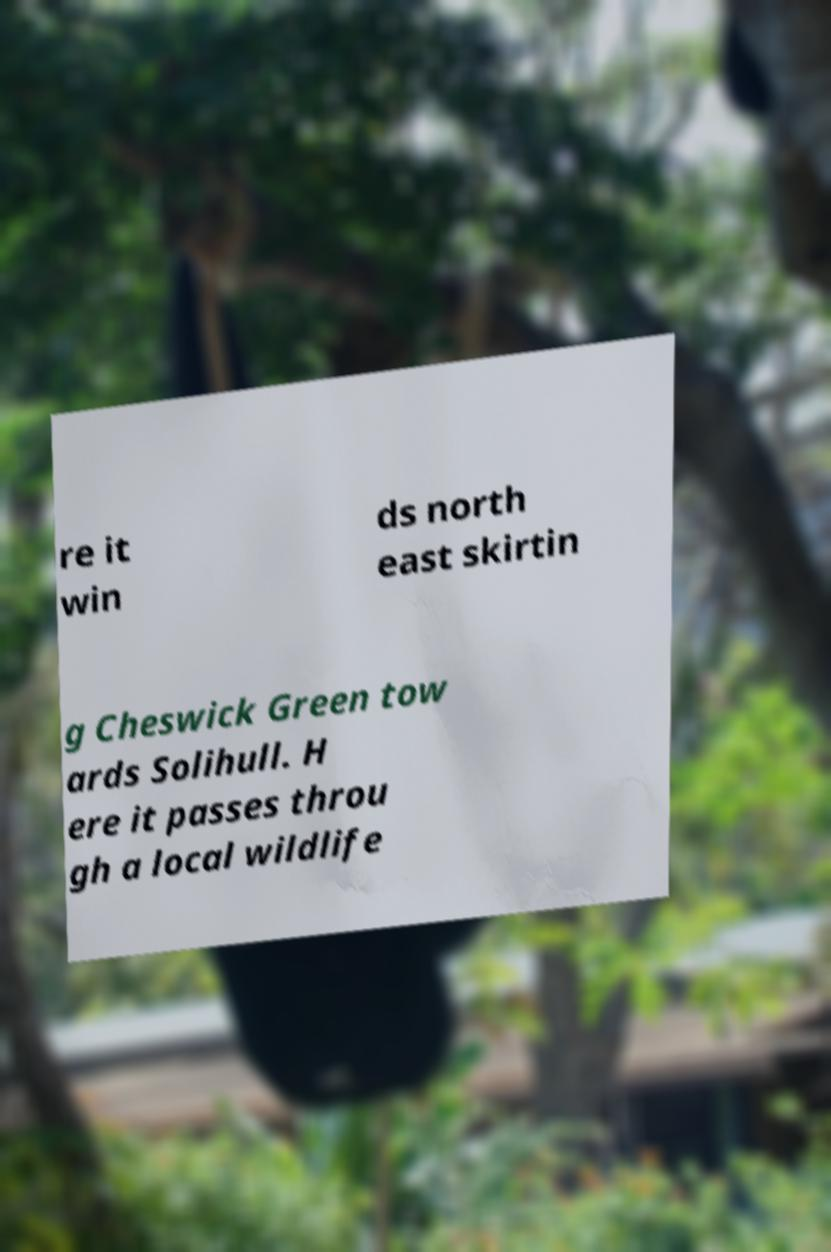Please read and relay the text visible in this image. What does it say? re it win ds north east skirtin g Cheswick Green tow ards Solihull. H ere it passes throu gh a local wildlife 